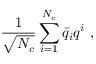<formula> <loc_0><loc_0><loc_500><loc_500>{ \frac { 1 } { \sqrt { N _ { c } } } } \sum _ { i = 1 } ^ { N _ { c } } \bar { q } _ { i } q ^ { i } \ ,</formula> 